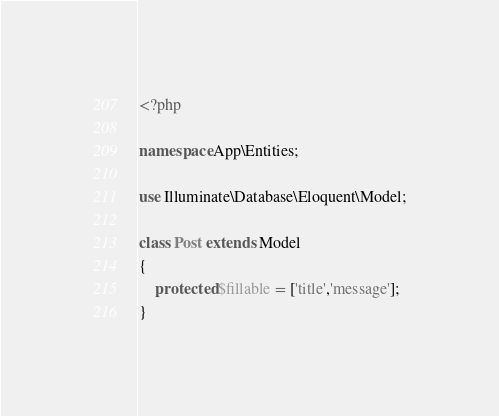Convert code to text. <code><loc_0><loc_0><loc_500><loc_500><_PHP_><?php

namespace App\Entities;

use Illuminate\Database\Eloquent\Model;

class Post extends Model
{
    protected $fillable = ['title','message'];
}
</code> 